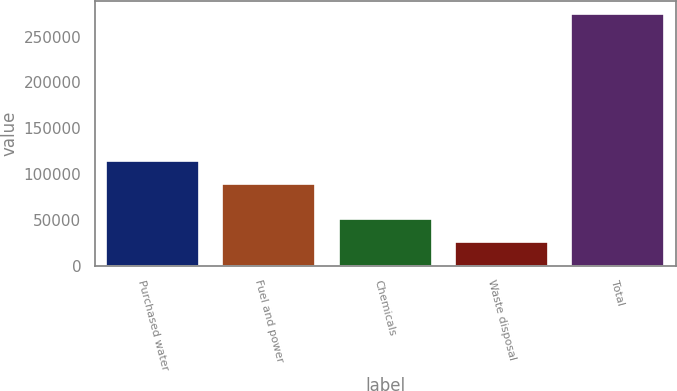Convert chart. <chart><loc_0><loc_0><loc_500><loc_500><bar_chart><fcel>Purchased water<fcel>Fuel and power<fcel>Chemicals<fcel>Waste disposal<fcel>Total<nl><fcel>114161<fcel>89282<fcel>50864.9<fcel>25986<fcel>274775<nl></chart> 